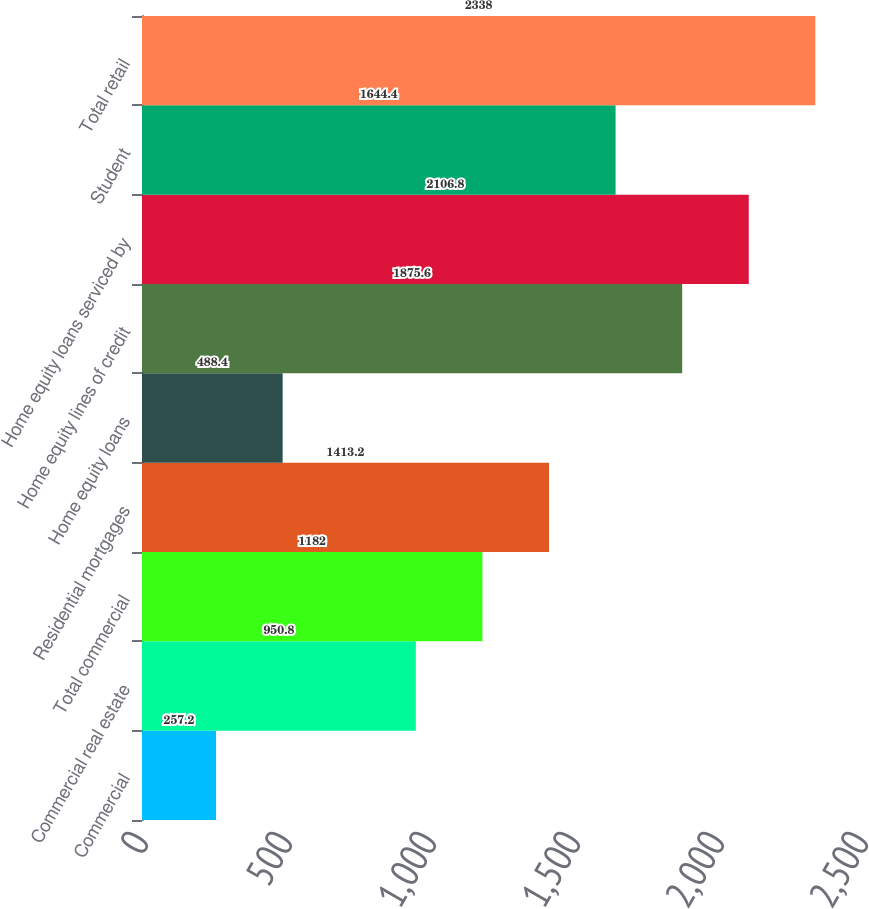Convert chart. <chart><loc_0><loc_0><loc_500><loc_500><bar_chart><fcel>Commercial<fcel>Commercial real estate<fcel>Total commercial<fcel>Residential mortgages<fcel>Home equity loans<fcel>Home equity lines of credit<fcel>Home equity loans serviced by<fcel>Student<fcel>Total retail<nl><fcel>257.2<fcel>950.8<fcel>1182<fcel>1413.2<fcel>488.4<fcel>1875.6<fcel>2106.8<fcel>1644.4<fcel>2338<nl></chart> 